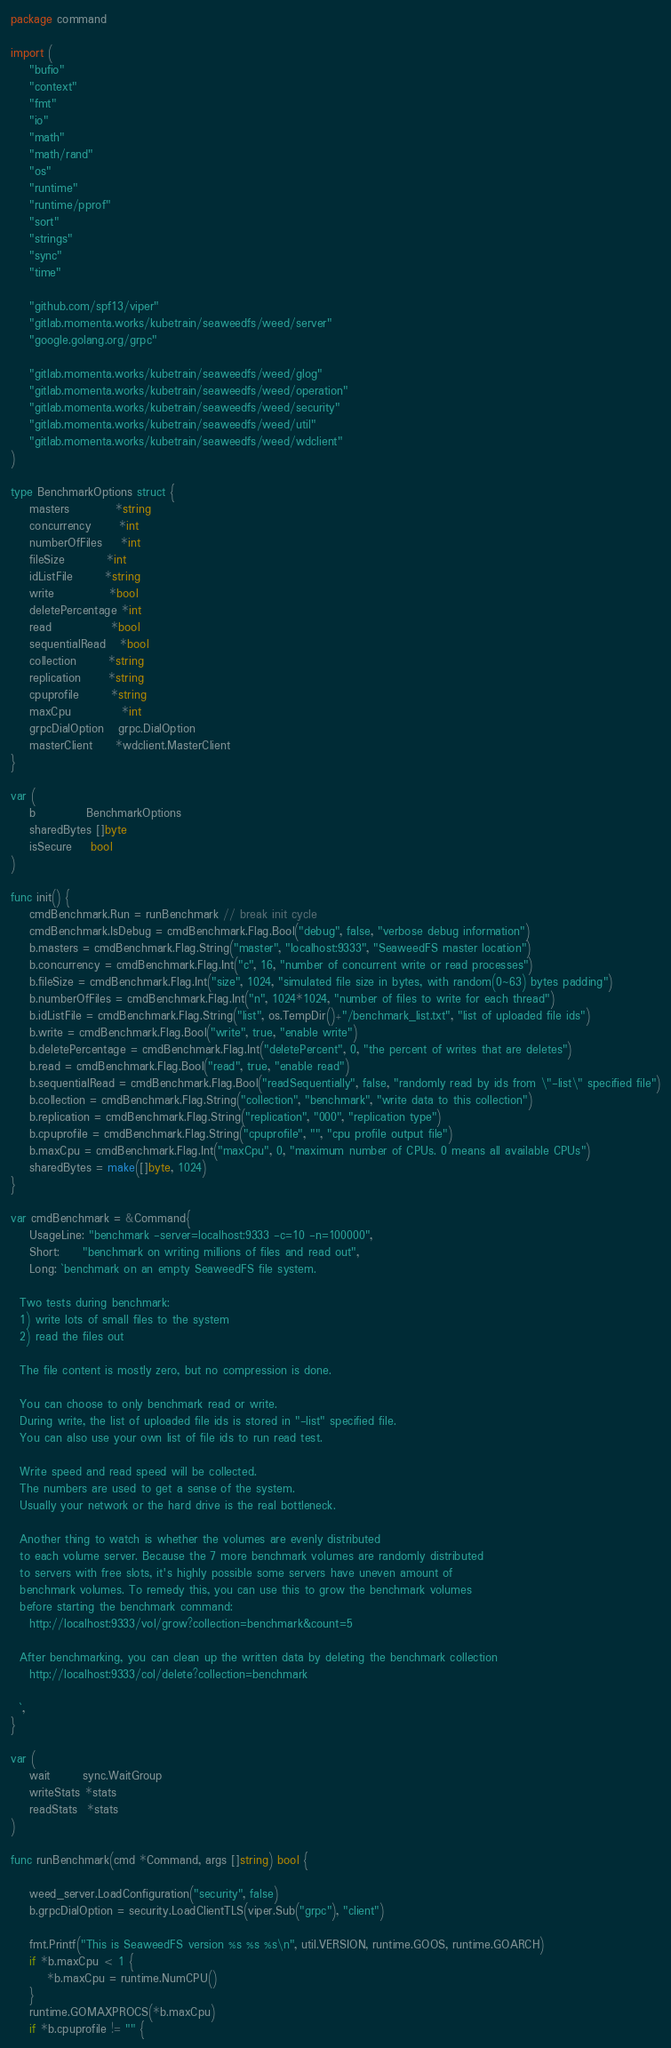<code> <loc_0><loc_0><loc_500><loc_500><_Go_>package command

import (
	"bufio"
	"context"
	"fmt"
	"io"
	"math"
	"math/rand"
	"os"
	"runtime"
	"runtime/pprof"
	"sort"
	"strings"
	"sync"
	"time"

	"github.com/spf13/viper"
	"gitlab.momenta.works/kubetrain/seaweedfs/weed/server"
	"google.golang.org/grpc"

	"gitlab.momenta.works/kubetrain/seaweedfs/weed/glog"
	"gitlab.momenta.works/kubetrain/seaweedfs/weed/operation"
	"gitlab.momenta.works/kubetrain/seaweedfs/weed/security"
	"gitlab.momenta.works/kubetrain/seaweedfs/weed/util"
	"gitlab.momenta.works/kubetrain/seaweedfs/weed/wdclient"
)

type BenchmarkOptions struct {
	masters          *string
	concurrency      *int
	numberOfFiles    *int
	fileSize         *int
	idListFile       *string
	write            *bool
	deletePercentage *int
	read             *bool
	sequentialRead   *bool
	collection       *string
	replication      *string
	cpuprofile       *string
	maxCpu           *int
	grpcDialOption   grpc.DialOption
	masterClient     *wdclient.MasterClient
}

var (
	b           BenchmarkOptions
	sharedBytes []byte
	isSecure    bool
)

func init() {
	cmdBenchmark.Run = runBenchmark // break init cycle
	cmdBenchmark.IsDebug = cmdBenchmark.Flag.Bool("debug", false, "verbose debug information")
	b.masters = cmdBenchmark.Flag.String("master", "localhost:9333", "SeaweedFS master location")
	b.concurrency = cmdBenchmark.Flag.Int("c", 16, "number of concurrent write or read processes")
	b.fileSize = cmdBenchmark.Flag.Int("size", 1024, "simulated file size in bytes, with random(0~63) bytes padding")
	b.numberOfFiles = cmdBenchmark.Flag.Int("n", 1024*1024, "number of files to write for each thread")
	b.idListFile = cmdBenchmark.Flag.String("list", os.TempDir()+"/benchmark_list.txt", "list of uploaded file ids")
	b.write = cmdBenchmark.Flag.Bool("write", true, "enable write")
	b.deletePercentage = cmdBenchmark.Flag.Int("deletePercent", 0, "the percent of writes that are deletes")
	b.read = cmdBenchmark.Flag.Bool("read", true, "enable read")
	b.sequentialRead = cmdBenchmark.Flag.Bool("readSequentially", false, "randomly read by ids from \"-list\" specified file")
	b.collection = cmdBenchmark.Flag.String("collection", "benchmark", "write data to this collection")
	b.replication = cmdBenchmark.Flag.String("replication", "000", "replication type")
	b.cpuprofile = cmdBenchmark.Flag.String("cpuprofile", "", "cpu profile output file")
	b.maxCpu = cmdBenchmark.Flag.Int("maxCpu", 0, "maximum number of CPUs. 0 means all available CPUs")
	sharedBytes = make([]byte, 1024)
}

var cmdBenchmark = &Command{
	UsageLine: "benchmark -server=localhost:9333 -c=10 -n=100000",
	Short:     "benchmark on writing millions of files and read out",
	Long: `benchmark on an empty SeaweedFS file system.

  Two tests during benchmark:
  1) write lots of small files to the system
  2) read the files out

  The file content is mostly zero, but no compression is done.

  You can choose to only benchmark read or write.
  During write, the list of uploaded file ids is stored in "-list" specified file.
  You can also use your own list of file ids to run read test.

  Write speed and read speed will be collected.
  The numbers are used to get a sense of the system.
  Usually your network or the hard drive is the real bottleneck.

  Another thing to watch is whether the volumes are evenly distributed
  to each volume server. Because the 7 more benchmark volumes are randomly distributed
  to servers with free slots, it's highly possible some servers have uneven amount of
  benchmark volumes. To remedy this, you can use this to grow the benchmark volumes
  before starting the benchmark command:
    http://localhost:9333/vol/grow?collection=benchmark&count=5

  After benchmarking, you can clean up the written data by deleting the benchmark collection
    http://localhost:9333/col/delete?collection=benchmark

  `,
}

var (
	wait       sync.WaitGroup
	writeStats *stats
	readStats  *stats
)

func runBenchmark(cmd *Command, args []string) bool {

	weed_server.LoadConfiguration("security", false)
	b.grpcDialOption = security.LoadClientTLS(viper.Sub("grpc"), "client")

	fmt.Printf("This is SeaweedFS version %s %s %s\n", util.VERSION, runtime.GOOS, runtime.GOARCH)
	if *b.maxCpu < 1 {
		*b.maxCpu = runtime.NumCPU()
	}
	runtime.GOMAXPROCS(*b.maxCpu)
	if *b.cpuprofile != "" {</code> 